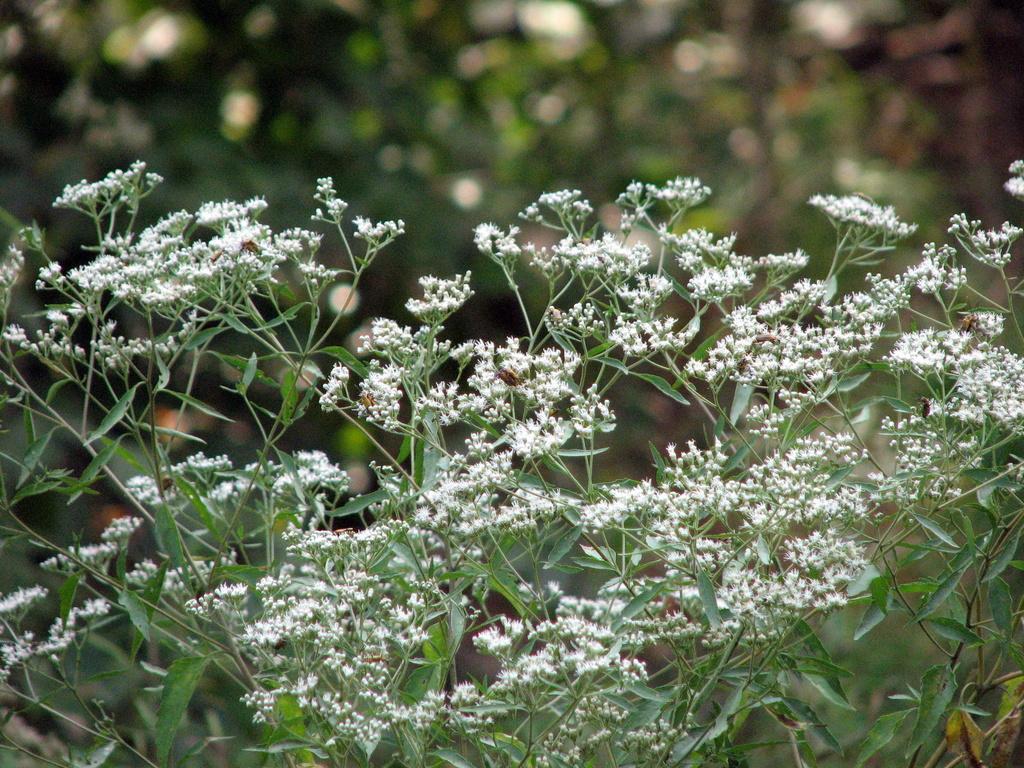Can you describe this image briefly? In this image, we can see some plants and we can see some flowers. 